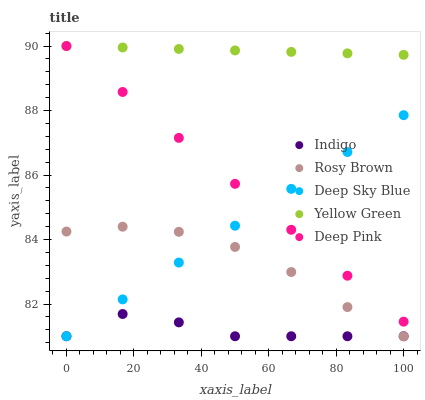Does Indigo have the minimum area under the curve?
Answer yes or no. Yes. Does Yellow Green have the maximum area under the curve?
Answer yes or no. Yes. Does Yellow Green have the minimum area under the curve?
Answer yes or no. No. Does Indigo have the maximum area under the curve?
Answer yes or no. No. Is Yellow Green the smoothest?
Answer yes or no. Yes. Is Indigo the roughest?
Answer yes or no. Yes. Is Indigo the smoothest?
Answer yes or no. No. Is Yellow Green the roughest?
Answer yes or no. No. Does Rosy Brown have the lowest value?
Answer yes or no. Yes. Does Yellow Green have the lowest value?
Answer yes or no. No. Does Deep Pink have the highest value?
Answer yes or no. Yes. Does Indigo have the highest value?
Answer yes or no. No. Is Indigo less than Deep Pink?
Answer yes or no. Yes. Is Yellow Green greater than Rosy Brown?
Answer yes or no. Yes. Does Indigo intersect Deep Sky Blue?
Answer yes or no. Yes. Is Indigo less than Deep Sky Blue?
Answer yes or no. No. Is Indigo greater than Deep Sky Blue?
Answer yes or no. No. Does Indigo intersect Deep Pink?
Answer yes or no. No. 